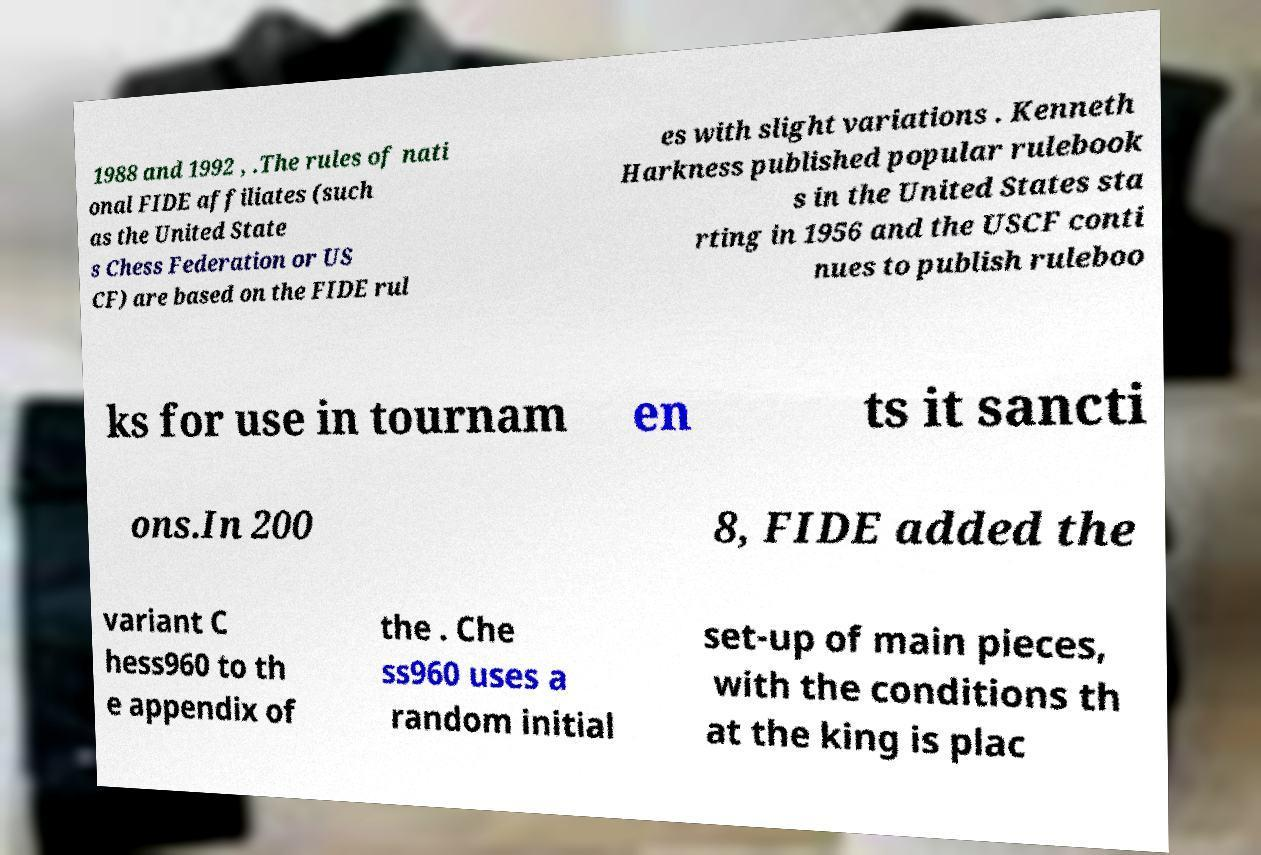Please read and relay the text visible in this image. What does it say? 1988 and 1992 , .The rules of nati onal FIDE affiliates (such as the United State s Chess Federation or US CF) are based on the FIDE rul es with slight variations . Kenneth Harkness published popular rulebook s in the United States sta rting in 1956 and the USCF conti nues to publish ruleboo ks for use in tournam en ts it sancti ons.In 200 8, FIDE added the variant C hess960 to th e appendix of the . Che ss960 uses a random initial set-up of main pieces, with the conditions th at the king is plac 